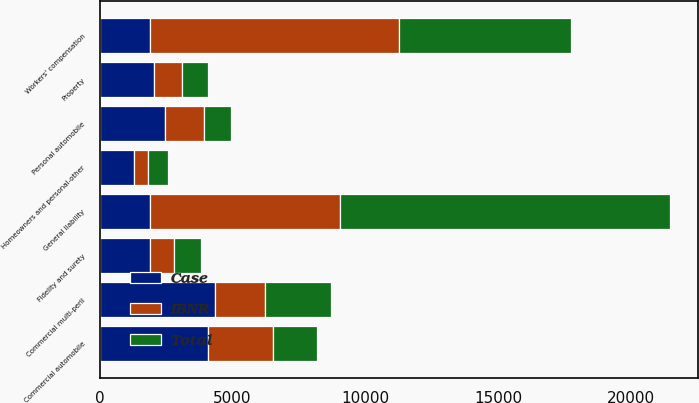Convert chart to OTSL. <chart><loc_0><loc_0><loc_500><loc_500><stacked_bar_chart><ecel><fcel>General liability<fcel>Property<fcel>Commercial multi-peril<fcel>Commercial automobile<fcel>Workers' compensation<fcel>Fidelity and surety<fcel>Personal automobile<fcel>Homeowners and personal-other<nl><fcel>IBNR<fcel>7180<fcel>1069<fcel>1860<fcel>2450<fcel>9373<fcel>878<fcel>1466<fcel>545<nl><fcel>Total<fcel>12388<fcel>963<fcel>2499<fcel>1640<fcel>6474<fcel>1026<fcel>998<fcel>739<nl><fcel>Case<fcel>1882<fcel>2032<fcel>4359<fcel>4090<fcel>1882<fcel>1904<fcel>2464<fcel>1284<nl></chart> 